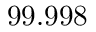<formula> <loc_0><loc_0><loc_500><loc_500>9 9 . 9 9 8 \</formula> 